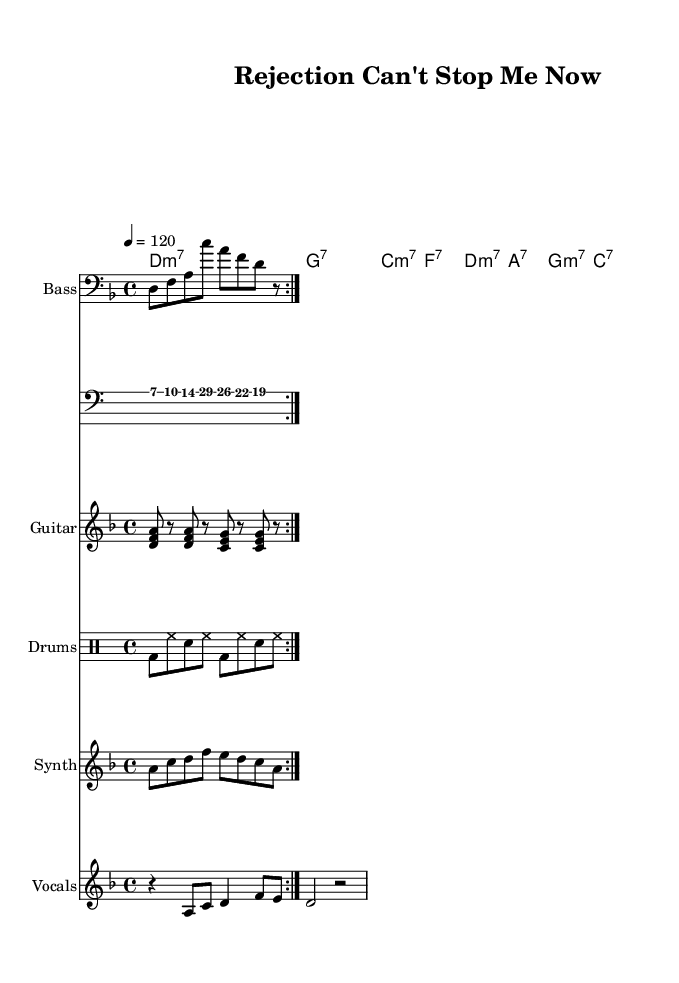What is the key signature of this music? The key signature is D minor, which is indicated at the beginning of the staff. D minor has one flat (B flat).
Answer: D minor What is the time signature of the piece? The time signature is 4/4, shown at the beginning of the score, indicating four beats per measure.
Answer: 4/4 What is the tempo marking for this piece? The tempo marking is 120 beats per minute, indicated by the "4 = 120" which specifies the number of beats per minute.
Answer: 120 How many times is the bass line repeated? The bass line is marked with "volta 2," indicating that the section is to be repeated two times.
Answer: 2 What is the primary theme of the lyrics? The lyrics focus on themes of perseverance and overcoming rejection, as evident in the phrases about resilience and seizing the day.
Answer: Perseverance Which chord is played in the chorus first? The first chord in the chorus is D minor 7, as shown in the chord progression beneath the vocal line.
Answer: D minor 7 What mood does the song convey through its title? The title "Rejection Can't Stop Me Now" suggests a defiant and uplifting mood, emphasizing determination in the face of obstacles.
Answer: Defiant 